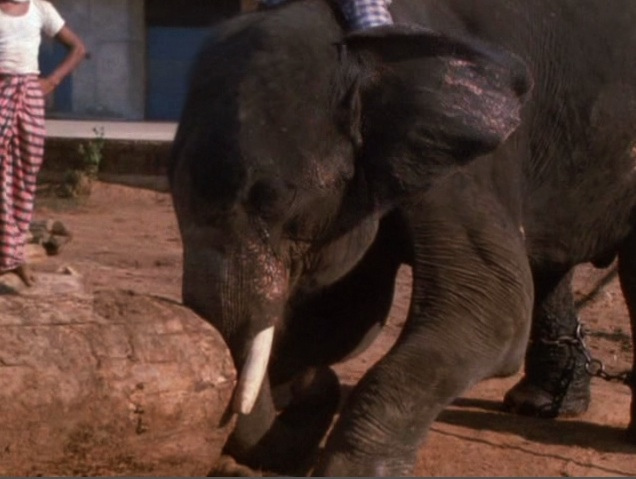<image>Are the men riding the elephants Indians? I don't know if the men riding the elephants are Indians. It can be yes or no. What kind of rock is this? I don't know what kind of rock this is. It could be a metamorphic, sedimentary, or granite rock. Is the elephant being controlled by humans? I don't know if the elephant is being controlled by humans. It can be both yes and no. Are the men riding the elephants Indians? I don't know if the men riding the elephants are Indians. It can be both Indians and non-Indians. What kind of rock is this? I don't know what kind of rock it is. It can be either metamorphic, sedimentary, or granite. Is the elephant being controlled by humans? I don't know if the elephant is being controlled by humans. 